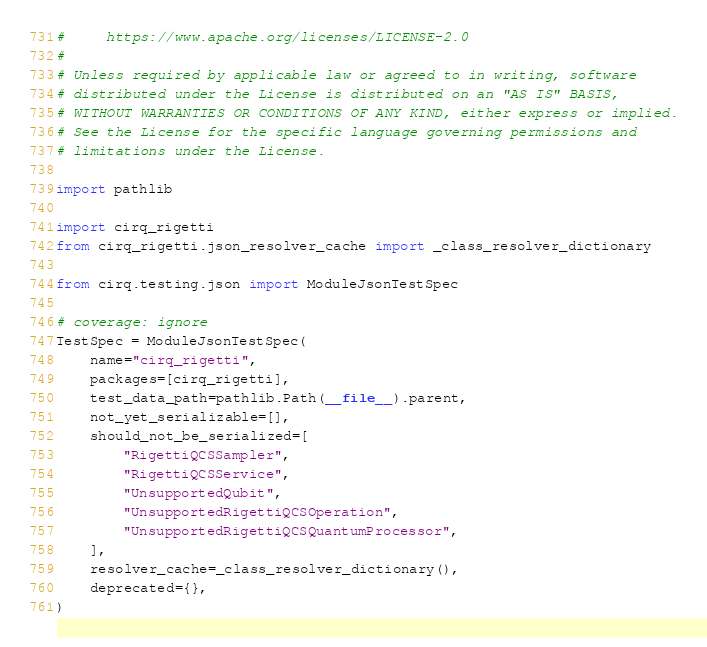<code> <loc_0><loc_0><loc_500><loc_500><_Python_>#     https://www.apache.org/licenses/LICENSE-2.0
#
# Unless required by applicable law or agreed to in writing, software
# distributed under the License is distributed on an "AS IS" BASIS,
# WITHOUT WARRANTIES OR CONDITIONS OF ANY KIND, either express or implied.
# See the License for the specific language governing permissions and
# limitations under the License.

import pathlib

import cirq_rigetti
from cirq_rigetti.json_resolver_cache import _class_resolver_dictionary

from cirq.testing.json import ModuleJsonTestSpec

# coverage: ignore
TestSpec = ModuleJsonTestSpec(
    name="cirq_rigetti",
    packages=[cirq_rigetti],
    test_data_path=pathlib.Path(__file__).parent,
    not_yet_serializable=[],
    should_not_be_serialized=[
        "RigettiQCSSampler",
        "RigettiQCSService",
        "UnsupportedQubit",
        "UnsupportedRigettiQCSOperation",
        "UnsupportedRigettiQCSQuantumProcessor",
    ],
    resolver_cache=_class_resolver_dictionary(),
    deprecated={},
)
</code> 